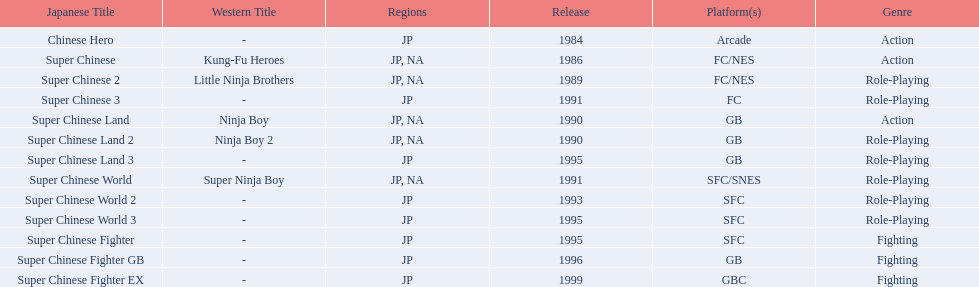How many super chinese international games were released 3. 